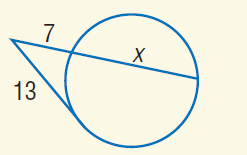Answer the mathemtical geometry problem and directly provide the correct option letter.
Question: Find x to the nearest tenth. Assume that segments that appear to be tangent are tangent.
Choices: A: 7 B: 13 C: 17.1 D: 21 C 